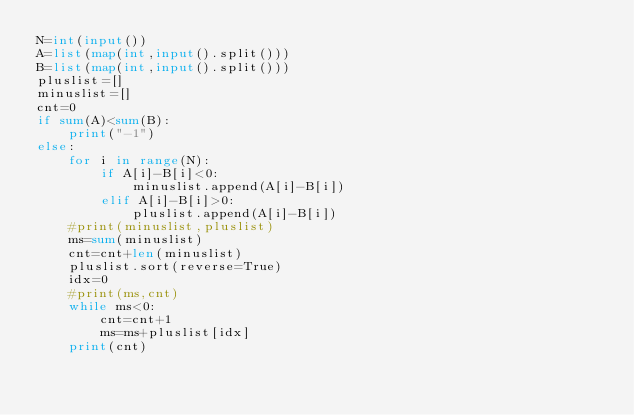Convert code to text. <code><loc_0><loc_0><loc_500><loc_500><_Python_>N=int(input())
A=list(map(int,input().split()))
B=list(map(int,input().split()))
pluslist=[]
minuslist=[]
cnt=0
if sum(A)<sum(B):
    print("-1")
else:
    for i in range(N):
        if A[i]-B[i]<0:
            minuslist.append(A[i]-B[i])
        elif A[i]-B[i]>0:
            pluslist.append(A[i]-B[i])
    #print(minuslist,pluslist)
    ms=sum(minuslist)
    cnt=cnt+len(minuslist)
    pluslist.sort(reverse=True)
    idx=0
    #print(ms,cnt)
    while ms<0:
        cnt=cnt+1
        ms=ms+pluslist[idx]
    print(cnt)</code> 